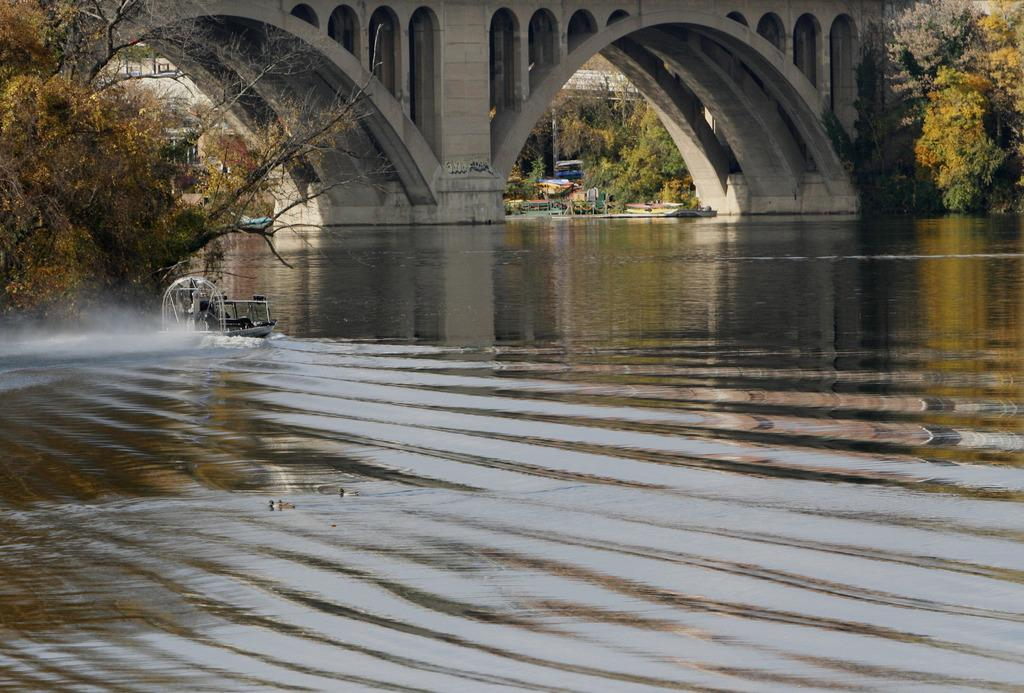What type of structure can be seen in the image? There is a bridge in the image. What natural elements are present in the image? Trees are present in the image. Where is the boat located in the image? The boat is on the left side of the image. What is in the middle of the image? There is water in the middle of the image. What type of horn can be heard coming from the bridge in the image? There is no horn present in the image, and therefore no sound can be heard. What kind of apparatus is used to control the boat in the image? The image does not show any apparatus used to control the boat; it only shows the boat on the left side of the image. 